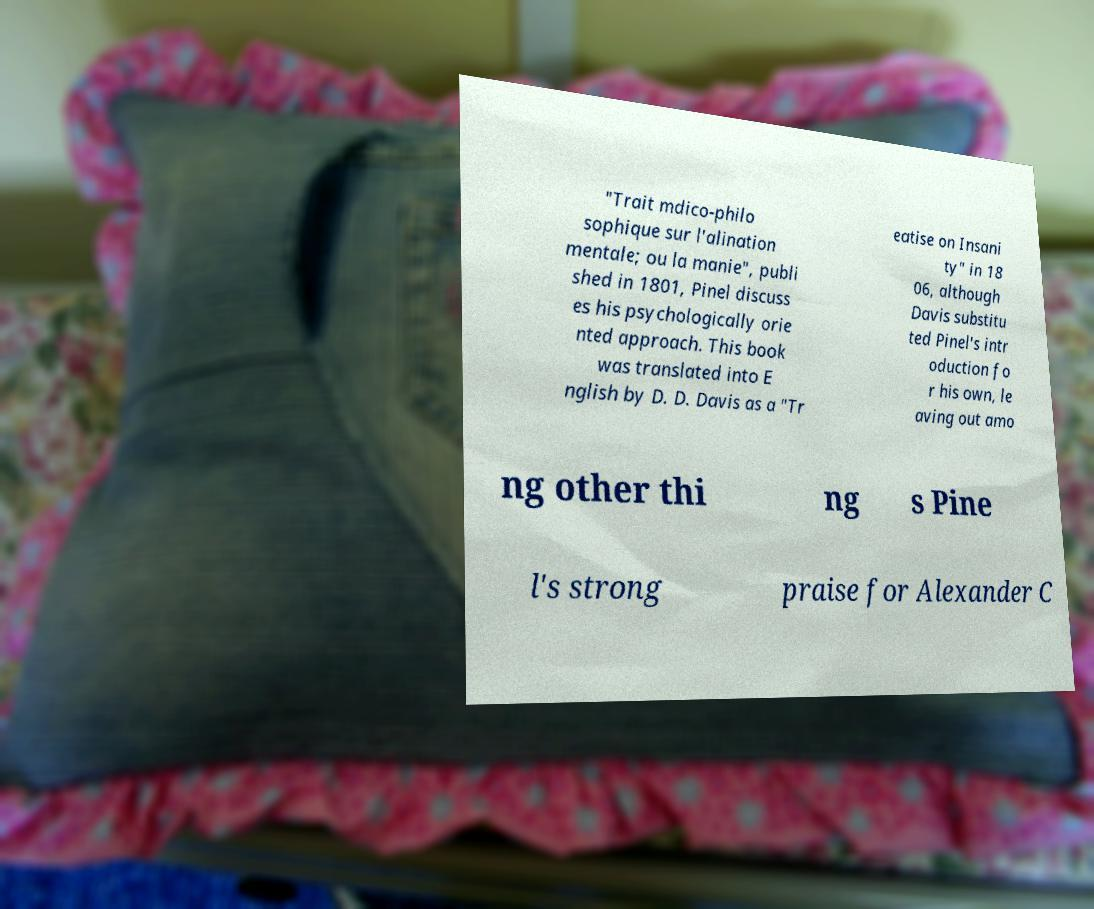Please identify and transcribe the text found in this image. "Trait mdico-philo sophique sur l'alination mentale; ou la manie", publi shed in 1801, Pinel discuss es his psychologically orie nted approach. This book was translated into E nglish by D. D. Davis as a "Tr eatise on Insani ty" in 18 06, although Davis substitu ted Pinel's intr oduction fo r his own, le aving out amo ng other thi ng s Pine l's strong praise for Alexander C 